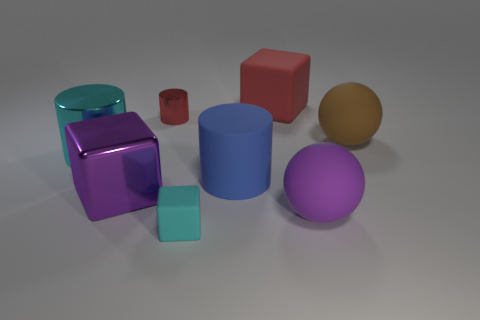Add 2 small blue metallic cubes. How many objects exist? 10 Subtract all cubes. How many objects are left? 5 Subtract 0 blue spheres. How many objects are left? 8 Subtract all big green shiny blocks. Subtract all purple matte balls. How many objects are left? 7 Add 8 red cubes. How many red cubes are left? 9 Add 3 small brown rubber blocks. How many small brown rubber blocks exist? 3 